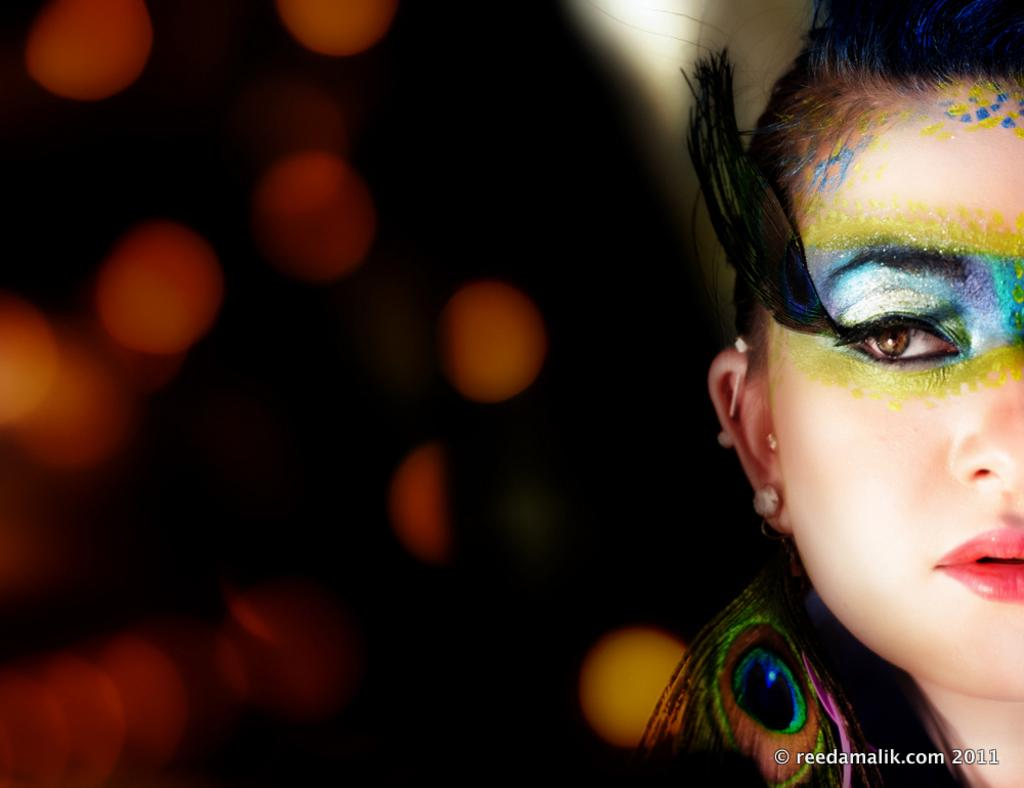Who or what is the main subject in the image? There is a person in the image. What part of the person is visible? The person's head is visible. How would you describe the background of the image? The background of the image is blurred. Are there any other objects or elements in the image besides the person? Yes, there is a peacock feather in the bottom right of the image. What type of food is being served in the lunchroom in the image? There is no lunchroom present in the image, so it is not possible to determine what food might be served. What government policy is being discussed in the image? There is no discussion of government policy in the image, as it primarily features a person and a peacock feather. 